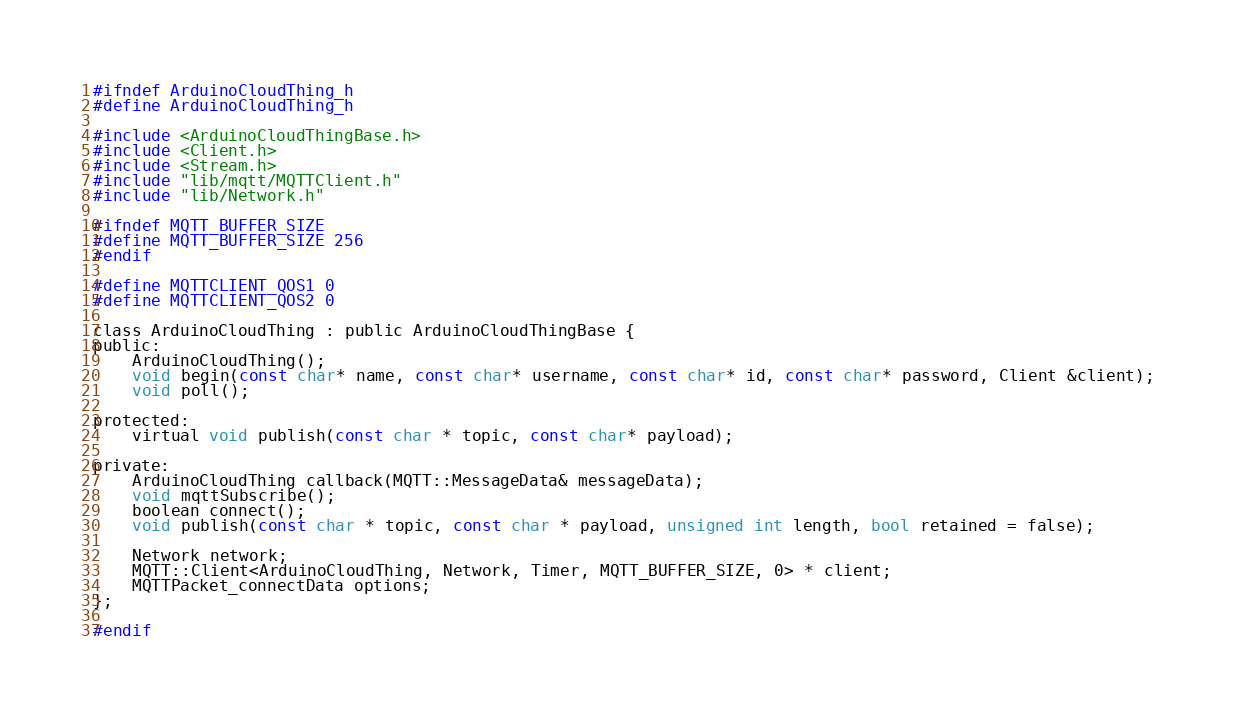<code> <loc_0><loc_0><loc_500><loc_500><_C_>#ifndef ArduinoCloudThing_h
#define ArduinoCloudThing_h

#include <ArduinoCloudThingBase.h>
#include <Client.h>
#include <Stream.h>
#include "lib/mqtt/MQTTClient.h"
#include "lib/Network.h"

#ifndef MQTT_BUFFER_SIZE
#define MQTT_BUFFER_SIZE 256
#endif

#define MQTTCLIENT_QOS1 0
#define MQTTCLIENT_QOS2 0

class ArduinoCloudThing : public ArduinoCloudThingBase {
public:
    ArduinoCloudThing();
    void begin(const char* name, const char* username, const char* id, const char* password, Client &client);
    void poll();

protected:
    virtual void publish(const char * topic, const char* payload);

private:
    ArduinoCloudThing callback(MQTT::MessageData& messageData);
    void mqttSubscribe();
    boolean connect();
    void publish(const char * topic, const char * payload, unsigned int length, bool retained = false);

    Network network;
    MQTT::Client<ArduinoCloudThing, Network, Timer, MQTT_BUFFER_SIZE, 0> * client;
    MQTTPacket_connectData options;
};

#endif
</code> 